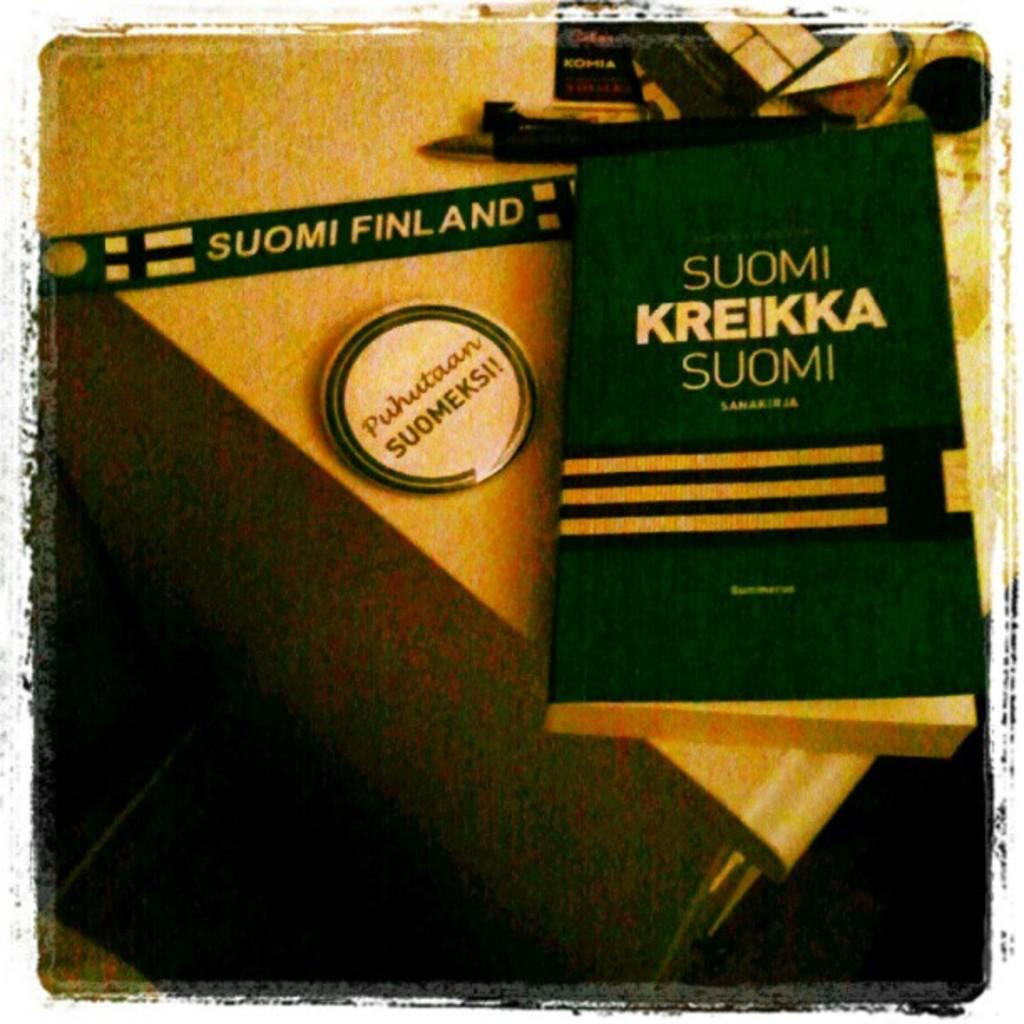Provide a one-sentence caption for the provided image. A green book called Suomi Kreikka Suomi is on a counter top. 